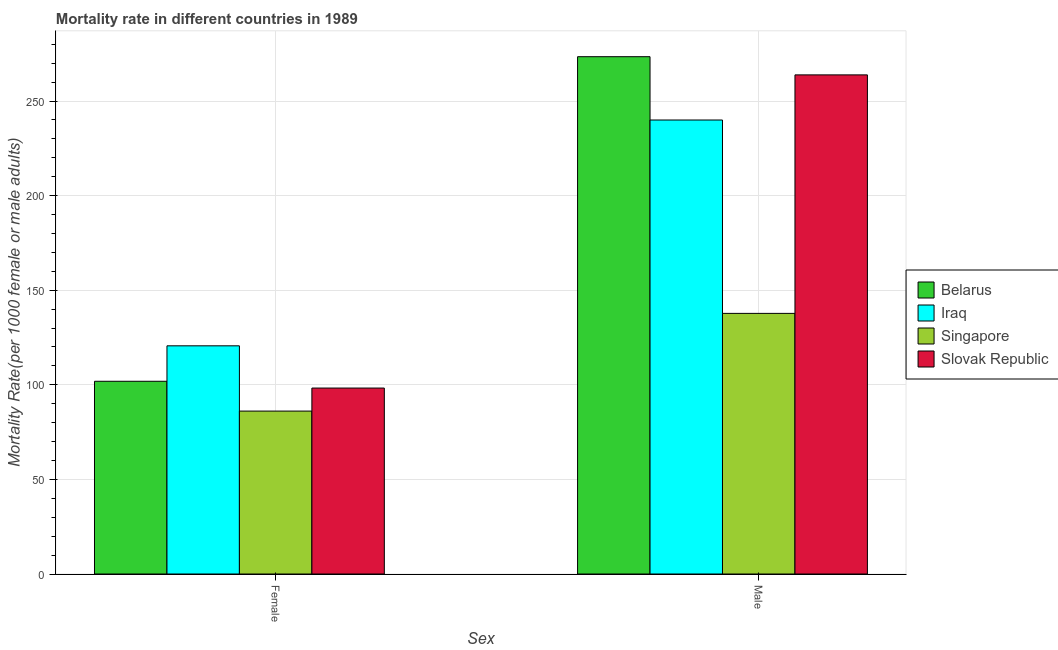How many groups of bars are there?
Provide a short and direct response. 2. Are the number of bars on each tick of the X-axis equal?
Keep it short and to the point. Yes. How many bars are there on the 1st tick from the left?
Your answer should be compact. 4. What is the male mortality rate in Belarus?
Give a very brief answer. 273.43. Across all countries, what is the maximum male mortality rate?
Give a very brief answer. 273.43. Across all countries, what is the minimum female mortality rate?
Provide a succinct answer. 86.11. In which country was the female mortality rate maximum?
Provide a short and direct response. Iraq. In which country was the female mortality rate minimum?
Your response must be concise. Singapore. What is the total male mortality rate in the graph?
Make the answer very short. 914.95. What is the difference between the female mortality rate in Slovak Republic and that in Belarus?
Your answer should be compact. -3.59. What is the difference between the female mortality rate in Belarus and the male mortality rate in Iraq?
Make the answer very short. -138.09. What is the average female mortality rate per country?
Ensure brevity in your answer.  101.72. What is the difference between the male mortality rate and female mortality rate in Belarus?
Offer a very short reply. 171.56. In how many countries, is the female mortality rate greater than 100 ?
Make the answer very short. 2. What is the ratio of the male mortality rate in Slovak Republic to that in Singapore?
Keep it short and to the point. 1.92. What does the 2nd bar from the left in Female represents?
Your answer should be compact. Iraq. What does the 4th bar from the right in Female represents?
Your answer should be compact. Belarus. What is the difference between two consecutive major ticks on the Y-axis?
Provide a succinct answer. 50. Where does the legend appear in the graph?
Your answer should be compact. Center right. How many legend labels are there?
Keep it short and to the point. 4. What is the title of the graph?
Give a very brief answer. Mortality rate in different countries in 1989. What is the label or title of the X-axis?
Your answer should be very brief. Sex. What is the label or title of the Y-axis?
Your answer should be compact. Mortality Rate(per 1000 female or male adults). What is the Mortality Rate(per 1000 female or male adults) in Belarus in Female?
Provide a succinct answer. 101.87. What is the Mortality Rate(per 1000 female or male adults) in Iraq in Female?
Your answer should be very brief. 120.61. What is the Mortality Rate(per 1000 female or male adults) of Singapore in Female?
Provide a short and direct response. 86.11. What is the Mortality Rate(per 1000 female or male adults) of Slovak Republic in Female?
Offer a terse response. 98.28. What is the Mortality Rate(per 1000 female or male adults) in Belarus in Male?
Your answer should be compact. 273.43. What is the Mortality Rate(per 1000 female or male adults) of Iraq in Male?
Your answer should be very brief. 239.96. What is the Mortality Rate(per 1000 female or male adults) in Singapore in Male?
Keep it short and to the point. 137.75. What is the Mortality Rate(per 1000 female or male adults) in Slovak Republic in Male?
Offer a terse response. 263.81. Across all Sex, what is the maximum Mortality Rate(per 1000 female or male adults) in Belarus?
Your answer should be very brief. 273.43. Across all Sex, what is the maximum Mortality Rate(per 1000 female or male adults) of Iraq?
Offer a terse response. 239.96. Across all Sex, what is the maximum Mortality Rate(per 1000 female or male adults) in Singapore?
Your answer should be compact. 137.75. Across all Sex, what is the maximum Mortality Rate(per 1000 female or male adults) in Slovak Republic?
Your answer should be very brief. 263.81. Across all Sex, what is the minimum Mortality Rate(per 1000 female or male adults) in Belarus?
Your answer should be compact. 101.87. Across all Sex, what is the minimum Mortality Rate(per 1000 female or male adults) of Iraq?
Keep it short and to the point. 120.61. Across all Sex, what is the minimum Mortality Rate(per 1000 female or male adults) in Singapore?
Your answer should be compact. 86.11. Across all Sex, what is the minimum Mortality Rate(per 1000 female or male adults) in Slovak Republic?
Make the answer very short. 98.28. What is the total Mortality Rate(per 1000 female or male adults) of Belarus in the graph?
Give a very brief answer. 375.29. What is the total Mortality Rate(per 1000 female or male adults) of Iraq in the graph?
Your answer should be very brief. 360.57. What is the total Mortality Rate(per 1000 female or male adults) of Singapore in the graph?
Provide a succinct answer. 223.87. What is the total Mortality Rate(per 1000 female or male adults) in Slovak Republic in the graph?
Make the answer very short. 362.09. What is the difference between the Mortality Rate(per 1000 female or male adults) in Belarus in Female and that in Male?
Keep it short and to the point. -171.56. What is the difference between the Mortality Rate(per 1000 female or male adults) of Iraq in Female and that in Male?
Ensure brevity in your answer.  -119.35. What is the difference between the Mortality Rate(per 1000 female or male adults) of Singapore in Female and that in Male?
Provide a succinct answer. -51.64. What is the difference between the Mortality Rate(per 1000 female or male adults) in Slovak Republic in Female and that in Male?
Offer a terse response. -165.53. What is the difference between the Mortality Rate(per 1000 female or male adults) in Belarus in Female and the Mortality Rate(per 1000 female or male adults) in Iraq in Male?
Your response must be concise. -138.09. What is the difference between the Mortality Rate(per 1000 female or male adults) of Belarus in Female and the Mortality Rate(per 1000 female or male adults) of Singapore in Male?
Give a very brief answer. -35.89. What is the difference between the Mortality Rate(per 1000 female or male adults) of Belarus in Female and the Mortality Rate(per 1000 female or male adults) of Slovak Republic in Male?
Make the answer very short. -161.94. What is the difference between the Mortality Rate(per 1000 female or male adults) in Iraq in Female and the Mortality Rate(per 1000 female or male adults) in Singapore in Male?
Provide a short and direct response. -17.15. What is the difference between the Mortality Rate(per 1000 female or male adults) in Iraq in Female and the Mortality Rate(per 1000 female or male adults) in Slovak Republic in Male?
Your response must be concise. -143.2. What is the difference between the Mortality Rate(per 1000 female or male adults) in Singapore in Female and the Mortality Rate(per 1000 female or male adults) in Slovak Republic in Male?
Ensure brevity in your answer.  -177.7. What is the average Mortality Rate(per 1000 female or male adults) of Belarus per Sex?
Make the answer very short. 187.65. What is the average Mortality Rate(per 1000 female or male adults) of Iraq per Sex?
Give a very brief answer. 180.28. What is the average Mortality Rate(per 1000 female or male adults) in Singapore per Sex?
Ensure brevity in your answer.  111.93. What is the average Mortality Rate(per 1000 female or male adults) of Slovak Republic per Sex?
Your answer should be compact. 181.05. What is the difference between the Mortality Rate(per 1000 female or male adults) of Belarus and Mortality Rate(per 1000 female or male adults) of Iraq in Female?
Your response must be concise. -18.74. What is the difference between the Mortality Rate(per 1000 female or male adults) of Belarus and Mortality Rate(per 1000 female or male adults) of Singapore in Female?
Ensure brevity in your answer.  15.76. What is the difference between the Mortality Rate(per 1000 female or male adults) of Belarus and Mortality Rate(per 1000 female or male adults) of Slovak Republic in Female?
Your response must be concise. 3.59. What is the difference between the Mortality Rate(per 1000 female or male adults) of Iraq and Mortality Rate(per 1000 female or male adults) of Singapore in Female?
Your answer should be very brief. 34.5. What is the difference between the Mortality Rate(per 1000 female or male adults) in Iraq and Mortality Rate(per 1000 female or male adults) in Slovak Republic in Female?
Ensure brevity in your answer.  22.32. What is the difference between the Mortality Rate(per 1000 female or male adults) in Singapore and Mortality Rate(per 1000 female or male adults) in Slovak Republic in Female?
Make the answer very short. -12.17. What is the difference between the Mortality Rate(per 1000 female or male adults) in Belarus and Mortality Rate(per 1000 female or male adults) in Iraq in Male?
Your answer should be compact. 33.46. What is the difference between the Mortality Rate(per 1000 female or male adults) of Belarus and Mortality Rate(per 1000 female or male adults) of Singapore in Male?
Your answer should be very brief. 135.67. What is the difference between the Mortality Rate(per 1000 female or male adults) of Belarus and Mortality Rate(per 1000 female or male adults) of Slovak Republic in Male?
Ensure brevity in your answer.  9.62. What is the difference between the Mortality Rate(per 1000 female or male adults) of Iraq and Mortality Rate(per 1000 female or male adults) of Singapore in Male?
Offer a terse response. 102.21. What is the difference between the Mortality Rate(per 1000 female or male adults) in Iraq and Mortality Rate(per 1000 female or male adults) in Slovak Republic in Male?
Give a very brief answer. -23.85. What is the difference between the Mortality Rate(per 1000 female or male adults) of Singapore and Mortality Rate(per 1000 female or male adults) of Slovak Republic in Male?
Your answer should be compact. -126.05. What is the ratio of the Mortality Rate(per 1000 female or male adults) of Belarus in Female to that in Male?
Offer a very short reply. 0.37. What is the ratio of the Mortality Rate(per 1000 female or male adults) in Iraq in Female to that in Male?
Provide a succinct answer. 0.5. What is the ratio of the Mortality Rate(per 1000 female or male adults) in Singapore in Female to that in Male?
Your response must be concise. 0.63. What is the ratio of the Mortality Rate(per 1000 female or male adults) of Slovak Republic in Female to that in Male?
Ensure brevity in your answer.  0.37. What is the difference between the highest and the second highest Mortality Rate(per 1000 female or male adults) of Belarus?
Your answer should be very brief. 171.56. What is the difference between the highest and the second highest Mortality Rate(per 1000 female or male adults) in Iraq?
Your answer should be very brief. 119.35. What is the difference between the highest and the second highest Mortality Rate(per 1000 female or male adults) in Singapore?
Offer a terse response. 51.64. What is the difference between the highest and the second highest Mortality Rate(per 1000 female or male adults) of Slovak Republic?
Your answer should be compact. 165.53. What is the difference between the highest and the lowest Mortality Rate(per 1000 female or male adults) of Belarus?
Offer a terse response. 171.56. What is the difference between the highest and the lowest Mortality Rate(per 1000 female or male adults) of Iraq?
Provide a short and direct response. 119.35. What is the difference between the highest and the lowest Mortality Rate(per 1000 female or male adults) of Singapore?
Your answer should be compact. 51.64. What is the difference between the highest and the lowest Mortality Rate(per 1000 female or male adults) in Slovak Republic?
Your response must be concise. 165.53. 